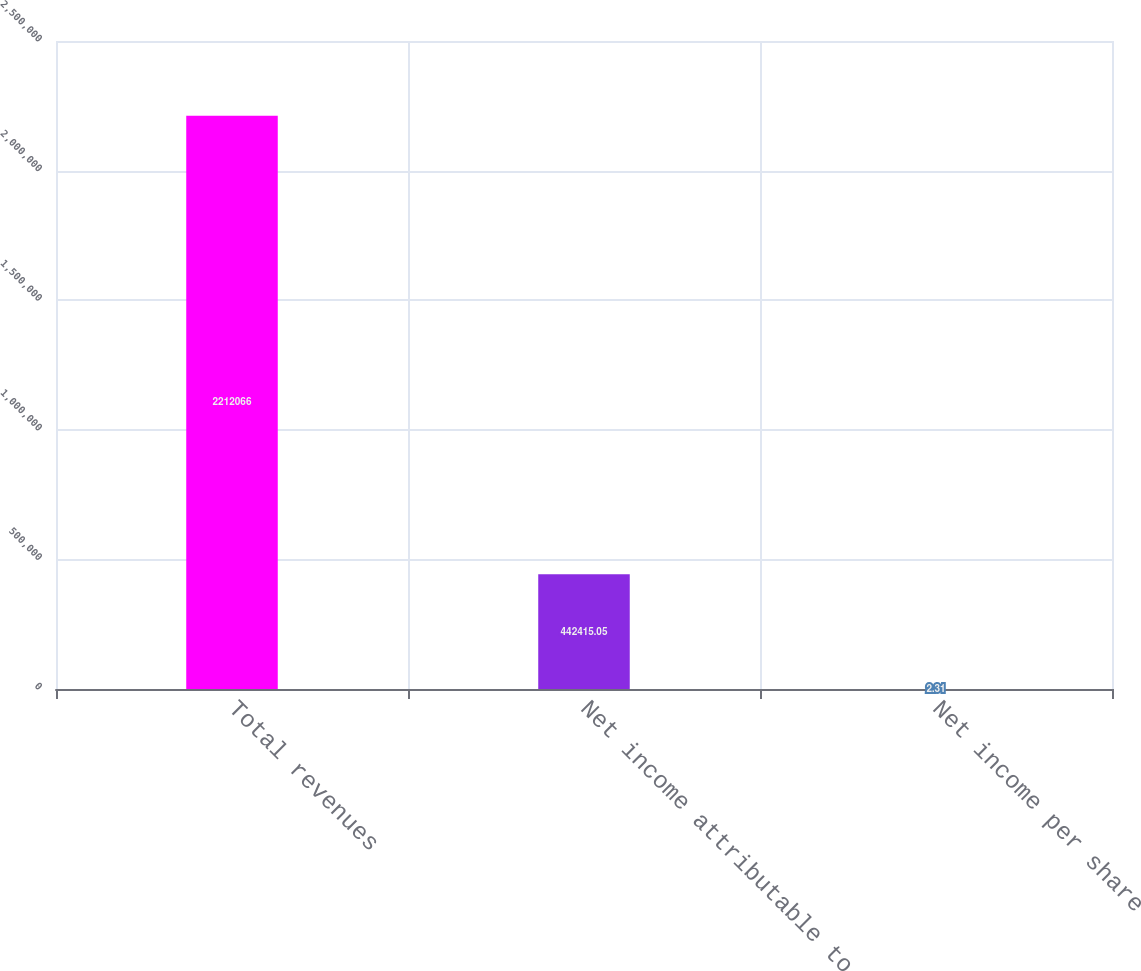Convert chart. <chart><loc_0><loc_0><loc_500><loc_500><bar_chart><fcel>Total revenues<fcel>Net income attributable to<fcel>Net income per share<nl><fcel>2.21207e+06<fcel>442415<fcel>2.31<nl></chart> 